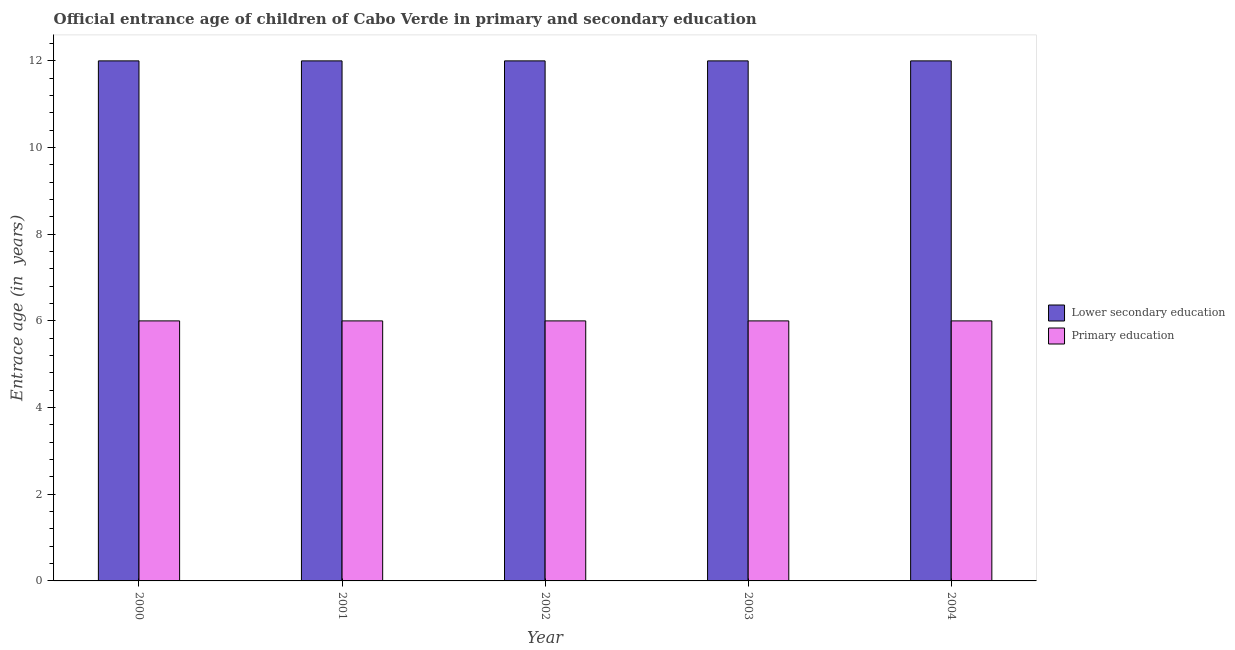Are the number of bars on each tick of the X-axis equal?
Your answer should be compact. Yes. In how many cases, is the number of bars for a given year not equal to the number of legend labels?
Your answer should be compact. 0. What is the total entrance age of chiildren in primary education in the graph?
Your answer should be compact. 30. What is the difference between the entrance age of chiildren in primary education in 2000 and that in 2004?
Your answer should be compact. 0. What is the difference between the entrance age of chiildren in primary education in 2001 and the entrance age of children in lower secondary education in 2002?
Your answer should be very brief. 0. What is the average entrance age of children in lower secondary education per year?
Keep it short and to the point. 12. In the year 2004, what is the difference between the entrance age of children in lower secondary education and entrance age of chiildren in primary education?
Keep it short and to the point. 0. In how many years, is the entrance age of children in lower secondary education greater than 8.8 years?
Your answer should be very brief. 5. Is the entrance age of chiildren in primary education in 2002 less than that in 2003?
Provide a succinct answer. No. What is the difference between the highest and the second highest entrance age of chiildren in primary education?
Ensure brevity in your answer.  0. What is the difference between the highest and the lowest entrance age of chiildren in primary education?
Your response must be concise. 0. What does the 2nd bar from the left in 2003 represents?
Ensure brevity in your answer.  Primary education. How many years are there in the graph?
Your response must be concise. 5. Are the values on the major ticks of Y-axis written in scientific E-notation?
Offer a very short reply. No. Does the graph contain grids?
Offer a very short reply. No. How are the legend labels stacked?
Your answer should be very brief. Vertical. What is the title of the graph?
Offer a terse response. Official entrance age of children of Cabo Verde in primary and secondary education. Does "Travel services" appear as one of the legend labels in the graph?
Keep it short and to the point. No. What is the label or title of the X-axis?
Your answer should be very brief. Year. What is the label or title of the Y-axis?
Keep it short and to the point. Entrace age (in  years). What is the Entrace age (in  years) in Primary education in 2000?
Offer a terse response. 6. What is the Entrace age (in  years) in Primary education in 2003?
Keep it short and to the point. 6. What is the Entrace age (in  years) of Lower secondary education in 2004?
Offer a terse response. 12. Across all years, what is the maximum Entrace age (in  years) of Primary education?
Offer a terse response. 6. Across all years, what is the minimum Entrace age (in  years) in Lower secondary education?
Give a very brief answer. 12. What is the difference between the Entrace age (in  years) of Lower secondary education in 2000 and that in 2002?
Give a very brief answer. 0. What is the difference between the Entrace age (in  years) in Primary education in 2000 and that in 2004?
Your answer should be very brief. 0. What is the difference between the Entrace age (in  years) of Lower secondary education in 2001 and that in 2002?
Provide a succinct answer. 0. What is the difference between the Entrace age (in  years) of Lower secondary education in 2001 and that in 2003?
Ensure brevity in your answer.  0. What is the difference between the Entrace age (in  years) in Lower secondary education in 2001 and that in 2004?
Offer a very short reply. 0. What is the difference between the Entrace age (in  years) of Lower secondary education in 2002 and that in 2004?
Your response must be concise. 0. What is the difference between the Entrace age (in  years) of Lower secondary education in 2003 and that in 2004?
Offer a very short reply. 0. What is the difference between the Entrace age (in  years) of Primary education in 2003 and that in 2004?
Provide a short and direct response. 0. What is the difference between the Entrace age (in  years) in Lower secondary education in 2000 and the Entrace age (in  years) in Primary education in 2001?
Provide a succinct answer. 6. What is the difference between the Entrace age (in  years) of Lower secondary education in 2000 and the Entrace age (in  years) of Primary education in 2002?
Offer a very short reply. 6. What is the difference between the Entrace age (in  years) in Lower secondary education in 2000 and the Entrace age (in  years) in Primary education in 2003?
Give a very brief answer. 6. What is the difference between the Entrace age (in  years) in Lower secondary education in 2000 and the Entrace age (in  years) in Primary education in 2004?
Your answer should be compact. 6. What is the difference between the Entrace age (in  years) in Lower secondary education in 2001 and the Entrace age (in  years) in Primary education in 2002?
Provide a succinct answer. 6. What is the difference between the Entrace age (in  years) in Lower secondary education in 2001 and the Entrace age (in  years) in Primary education in 2003?
Keep it short and to the point. 6. What is the difference between the Entrace age (in  years) in Lower secondary education in 2001 and the Entrace age (in  years) in Primary education in 2004?
Make the answer very short. 6. What is the difference between the Entrace age (in  years) in Lower secondary education in 2002 and the Entrace age (in  years) in Primary education in 2003?
Keep it short and to the point. 6. What is the average Entrace age (in  years) in Lower secondary education per year?
Your answer should be compact. 12. What is the average Entrace age (in  years) of Primary education per year?
Offer a very short reply. 6. In the year 2001, what is the difference between the Entrace age (in  years) in Lower secondary education and Entrace age (in  years) in Primary education?
Your answer should be very brief. 6. In the year 2002, what is the difference between the Entrace age (in  years) of Lower secondary education and Entrace age (in  years) of Primary education?
Keep it short and to the point. 6. In the year 2003, what is the difference between the Entrace age (in  years) in Lower secondary education and Entrace age (in  years) in Primary education?
Give a very brief answer. 6. In the year 2004, what is the difference between the Entrace age (in  years) of Lower secondary education and Entrace age (in  years) of Primary education?
Offer a terse response. 6. What is the ratio of the Entrace age (in  years) in Primary education in 2000 to that in 2001?
Make the answer very short. 1. What is the ratio of the Entrace age (in  years) in Primary education in 2000 to that in 2003?
Offer a very short reply. 1. What is the ratio of the Entrace age (in  years) in Lower secondary education in 2000 to that in 2004?
Your answer should be compact. 1. What is the ratio of the Entrace age (in  years) in Primary education in 2000 to that in 2004?
Provide a short and direct response. 1. What is the ratio of the Entrace age (in  years) of Lower secondary education in 2001 to that in 2002?
Provide a succinct answer. 1. What is the ratio of the Entrace age (in  years) of Primary education in 2001 to that in 2002?
Offer a very short reply. 1. What is the ratio of the Entrace age (in  years) of Lower secondary education in 2001 to that in 2003?
Provide a succinct answer. 1. What is the ratio of the Entrace age (in  years) in Primary education in 2001 to that in 2003?
Provide a succinct answer. 1. What is the ratio of the Entrace age (in  years) in Lower secondary education in 2002 to that in 2003?
Provide a succinct answer. 1. What is the ratio of the Entrace age (in  years) of Lower secondary education in 2002 to that in 2004?
Offer a terse response. 1. What is the ratio of the Entrace age (in  years) of Primary education in 2002 to that in 2004?
Offer a terse response. 1. What is the difference between the highest and the lowest Entrace age (in  years) in Lower secondary education?
Offer a terse response. 0. 